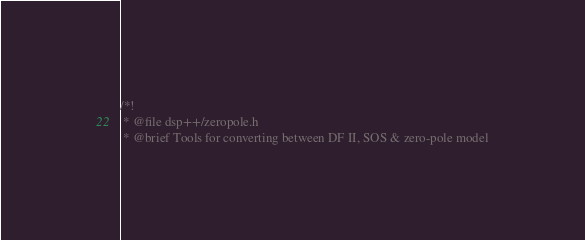Convert code to text. <code><loc_0><loc_0><loc_500><loc_500><_C_>/*!
 * @file dsp++/zeropole.h
 * @brief Tools for converting between DF II, SOS & zero-pole model</code> 